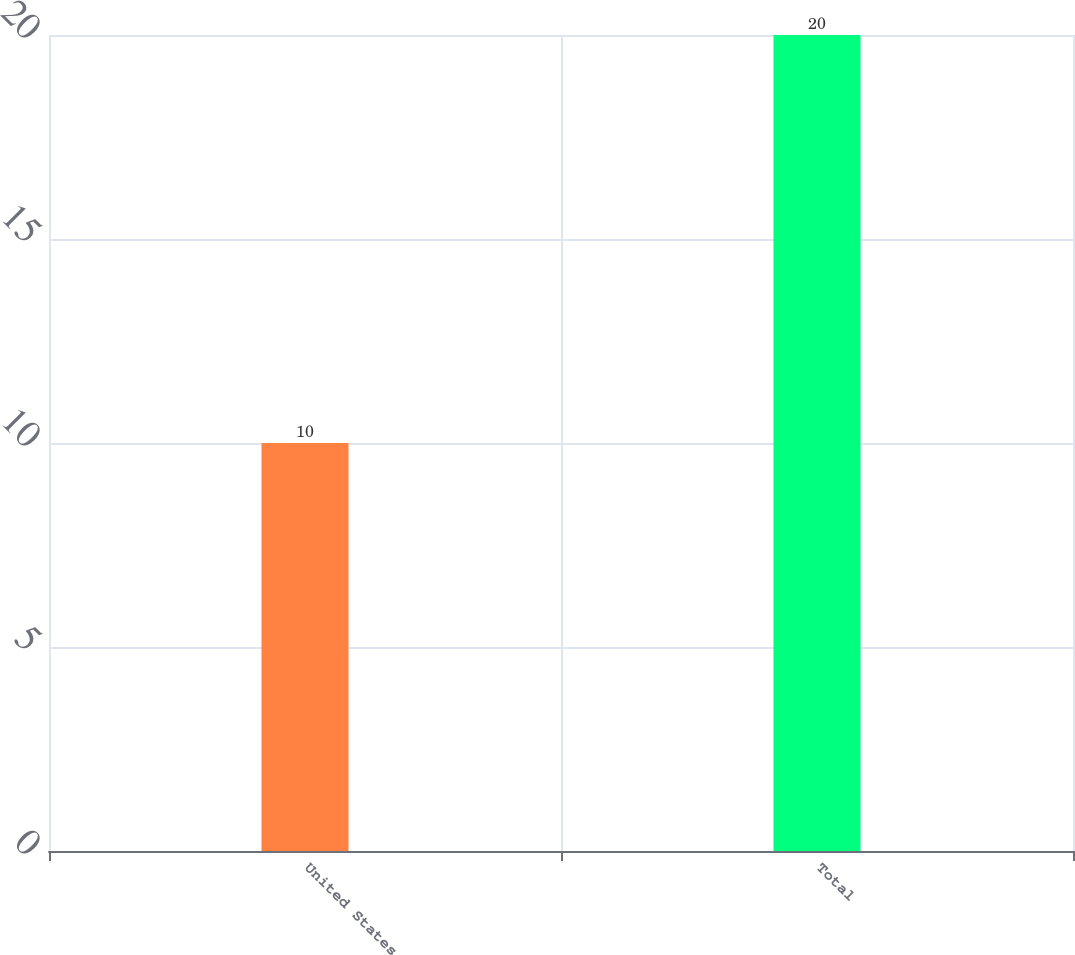<chart> <loc_0><loc_0><loc_500><loc_500><bar_chart><fcel>United States<fcel>Total<nl><fcel>10<fcel>20<nl></chart> 